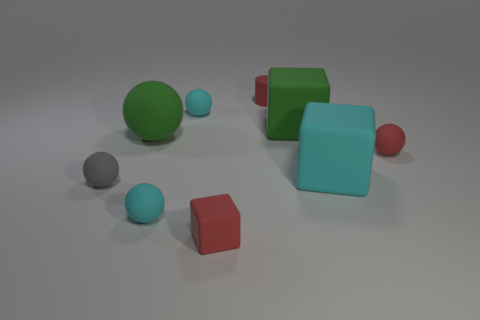There is a gray thing that is made of the same material as the tiny red block; what is its shape? sphere 